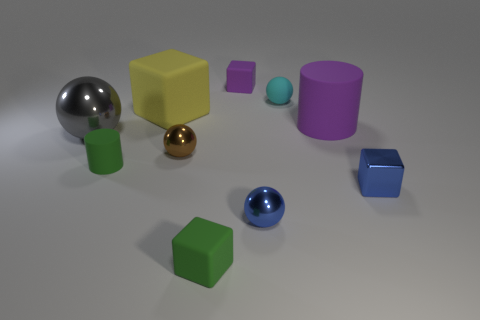Subtract 1 balls. How many balls are left? 3 Subtract all cubes. How many objects are left? 6 Subtract all small rubber balls. Subtract all small brown rubber objects. How many objects are left? 9 Add 5 tiny blue objects. How many tiny blue objects are left? 7 Add 2 small blue metallic balls. How many small blue metallic balls exist? 3 Subtract 1 purple cylinders. How many objects are left? 9 